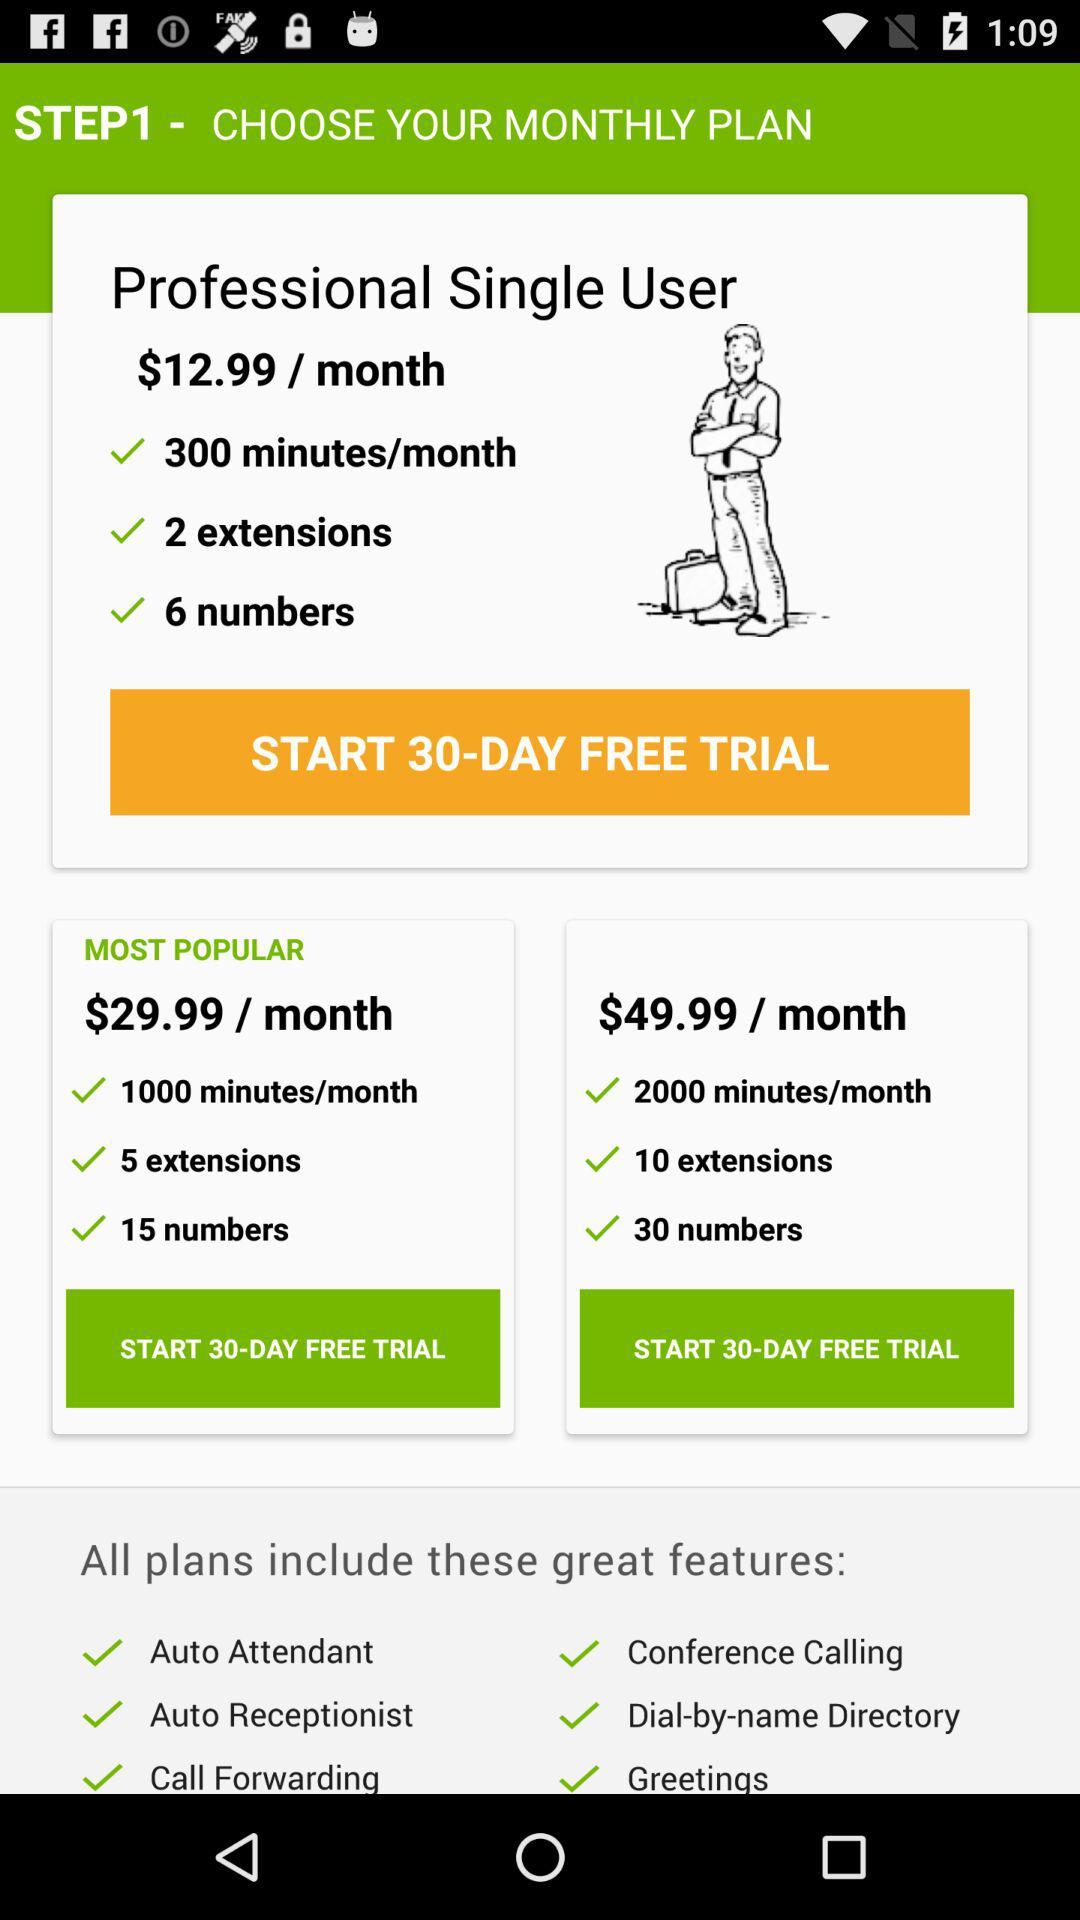Which plan costs $12.99? The plan is "Professional Single User". 